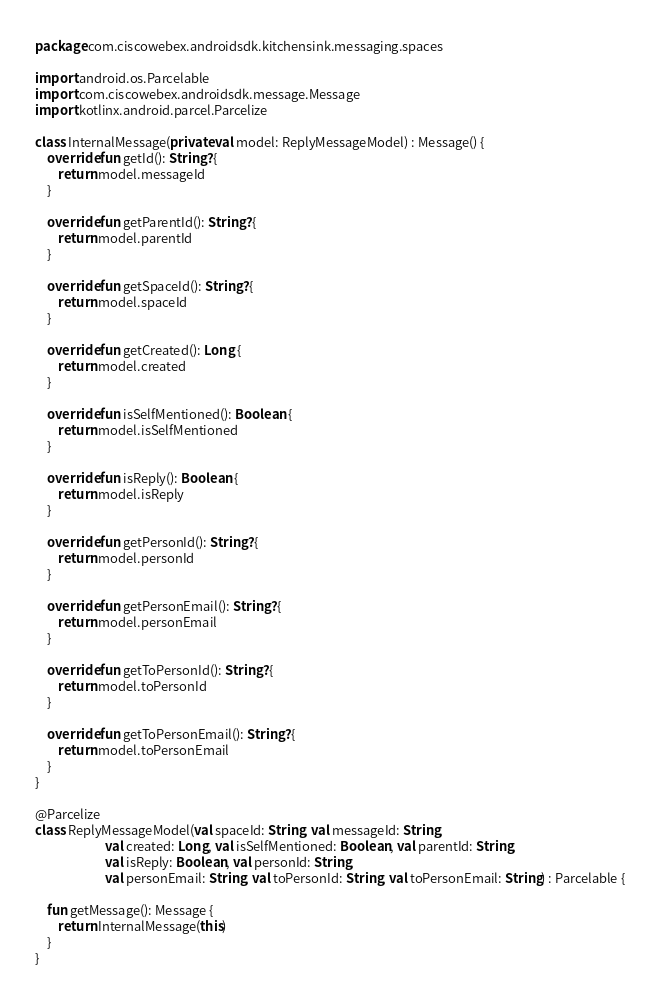Convert code to text. <code><loc_0><loc_0><loc_500><loc_500><_Kotlin_>package com.ciscowebex.androidsdk.kitchensink.messaging.spaces

import android.os.Parcelable
import com.ciscowebex.androidsdk.message.Message
import kotlinx.android.parcel.Parcelize

class InternalMessage(private val model: ReplyMessageModel) : Message() {
    override fun getId(): String? {
        return model.messageId
    }

    override fun getParentId(): String? {
        return model.parentId
    }

    override fun getSpaceId(): String? {
        return model.spaceId
    }

    override fun getCreated(): Long {
        return model.created
    }

    override fun isSelfMentioned(): Boolean {
        return model.isSelfMentioned
    }

    override fun isReply(): Boolean {
        return model.isReply
    }

    override fun getPersonId(): String? {
        return model.personId
    }

    override fun getPersonEmail(): String? {
        return model.personEmail
    }

    override fun getToPersonId(): String? {
        return model.toPersonId
    }

    override fun getToPersonEmail(): String? {
        return model.toPersonEmail
    }
}

@Parcelize
class ReplyMessageModel(val spaceId: String, val messageId: String,
                        val created: Long, val isSelfMentioned: Boolean, val parentId: String,
                        val isReply: Boolean, val personId: String,
                        val personEmail: String, val toPersonId: String, val toPersonEmail: String) : Parcelable {

    fun getMessage(): Message {
        return InternalMessage(this)
    }
}
</code> 